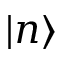Convert formula to latex. <formula><loc_0><loc_0><loc_500><loc_500>| n \rangle</formula> 